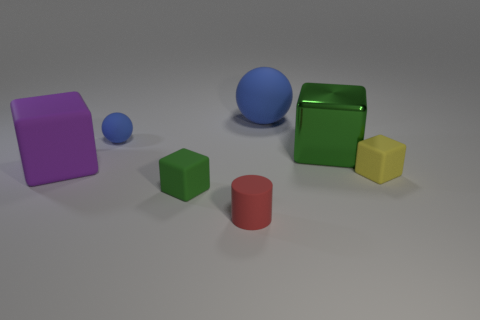There is a big rubber object that is left of the small blue sphere; what is its shape?
Provide a short and direct response. Cube. Are there any other things that are the same material as the red thing?
Give a very brief answer. Yes. Is the number of small blue rubber objects on the left side of the large purple object greater than the number of big green cubes?
Give a very brief answer. No. What number of blue matte things are right of the large rubber thing behind the metallic cube that is behind the small green block?
Give a very brief answer. 0. There is a green thing left of the tiny red rubber thing; does it have the same size as the green object that is behind the big purple rubber thing?
Offer a terse response. No. There is a green block in front of the matte cube left of the green rubber object; what is its material?
Provide a succinct answer. Rubber. How many things are either tiny balls to the left of the large metal object or blocks?
Give a very brief answer. 5. Are there an equal number of cylinders behind the purple rubber thing and blue matte balls that are right of the small green object?
Offer a terse response. No. The big cube that is to the right of the blue object on the right side of the green thing that is in front of the large purple rubber object is made of what material?
Offer a terse response. Metal. What size is the block that is both behind the yellow rubber cube and to the right of the large purple rubber object?
Offer a very short reply. Large. 